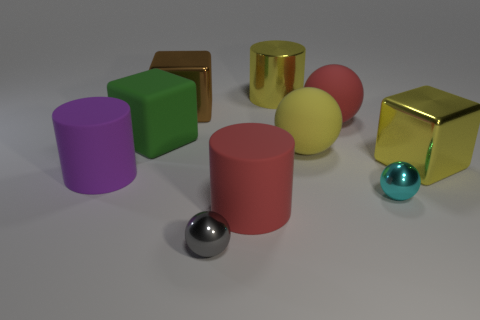What shape is the big metallic object that is the same color as the metal cylinder?
Offer a terse response. Cube. There is a matte cube; is it the same color as the cylinder in front of the purple rubber cylinder?
Provide a short and direct response. No. There is a metal block in front of the green matte object; is it the same size as the large yellow matte ball?
Ensure brevity in your answer.  Yes. What material is the yellow thing that is the same shape as the gray thing?
Provide a short and direct response. Rubber. Does the big green rubber object have the same shape as the yellow matte object?
Your answer should be very brief. No. There is a block that is behind the green thing; what number of large purple cylinders are to the left of it?
Keep it short and to the point. 1. What shape is the yellow thing that is made of the same material as the purple thing?
Offer a very short reply. Sphere. How many purple things are large rubber blocks or large rubber objects?
Make the answer very short. 1. Is there a yellow rubber object that is on the left side of the large shiny cube that is to the left of the big yellow thing behind the brown metal thing?
Offer a terse response. No. Is the number of rubber objects less than the number of small red matte spheres?
Your response must be concise. No. 